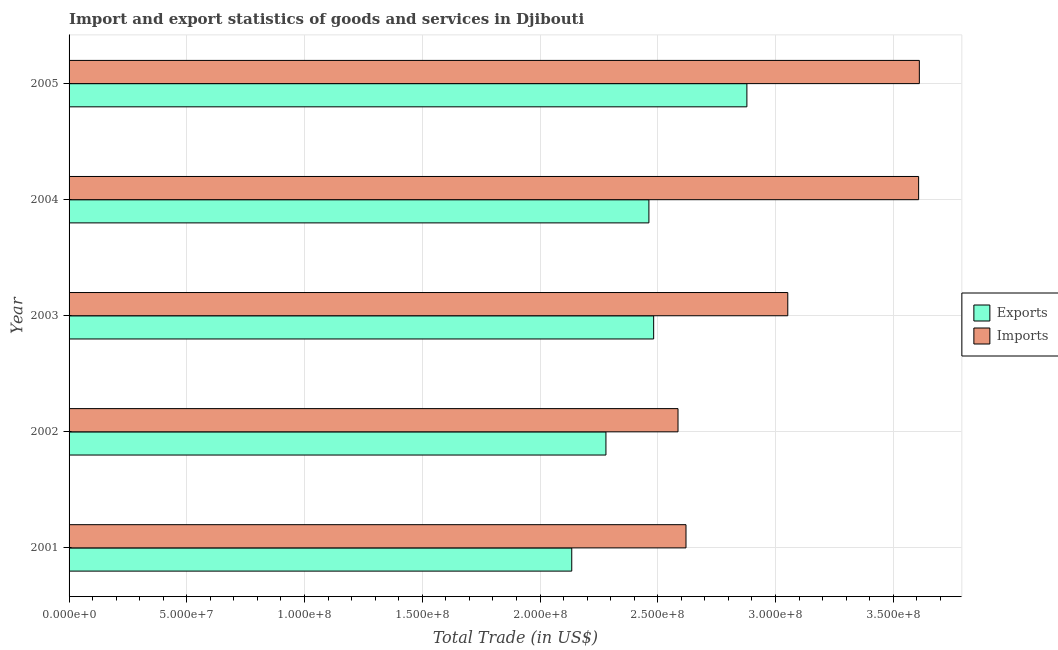How many different coloured bars are there?
Your answer should be compact. 2. How many groups of bars are there?
Offer a terse response. 5. Are the number of bars per tick equal to the number of legend labels?
Make the answer very short. Yes. How many bars are there on the 1st tick from the bottom?
Make the answer very short. 2. In how many cases, is the number of bars for a given year not equal to the number of legend labels?
Make the answer very short. 0. What is the export of goods and services in 2001?
Keep it short and to the point. 2.13e+08. Across all years, what is the maximum export of goods and services?
Provide a short and direct response. 2.88e+08. Across all years, what is the minimum export of goods and services?
Provide a succinct answer. 2.13e+08. In which year was the export of goods and services maximum?
Provide a succinct answer. 2005. What is the total imports of goods and services in the graph?
Provide a succinct answer. 1.55e+09. What is the difference between the export of goods and services in 2003 and that in 2005?
Keep it short and to the point. -3.96e+07. What is the difference between the export of goods and services in 2003 and the imports of goods and services in 2001?
Keep it short and to the point. -1.37e+07. What is the average export of goods and services per year?
Make the answer very short. 2.45e+08. In the year 2003, what is the difference between the imports of goods and services and export of goods and services?
Offer a very short reply. 5.70e+07. What is the ratio of the export of goods and services in 2004 to that in 2005?
Your answer should be compact. 0.85. Is the export of goods and services in 2001 less than that in 2004?
Give a very brief answer. Yes. Is the difference between the imports of goods and services in 2003 and 2004 greater than the difference between the export of goods and services in 2003 and 2004?
Your answer should be compact. No. What is the difference between the highest and the second highest imports of goods and services?
Your answer should be compact. 3.00e+05. What is the difference between the highest and the lowest imports of goods and services?
Provide a succinct answer. 1.02e+08. In how many years, is the export of goods and services greater than the average export of goods and services taken over all years?
Offer a very short reply. 3. What does the 1st bar from the top in 2003 represents?
Give a very brief answer. Imports. What does the 1st bar from the bottom in 2004 represents?
Your answer should be compact. Exports. How many bars are there?
Your answer should be very brief. 10. What is the difference between two consecutive major ticks on the X-axis?
Make the answer very short. 5.00e+07. Where does the legend appear in the graph?
Your answer should be compact. Center right. How are the legend labels stacked?
Keep it short and to the point. Vertical. What is the title of the graph?
Provide a succinct answer. Import and export statistics of goods and services in Djibouti. Does "Number of departures" appear as one of the legend labels in the graph?
Make the answer very short. No. What is the label or title of the X-axis?
Provide a succinct answer. Total Trade (in US$). What is the label or title of the Y-axis?
Make the answer very short. Year. What is the Total Trade (in US$) in Exports in 2001?
Offer a very short reply. 2.13e+08. What is the Total Trade (in US$) in Imports in 2001?
Provide a succinct answer. 2.62e+08. What is the Total Trade (in US$) in Exports in 2002?
Offer a very short reply. 2.28e+08. What is the Total Trade (in US$) in Imports in 2002?
Make the answer very short. 2.59e+08. What is the Total Trade (in US$) of Exports in 2003?
Your response must be concise. 2.48e+08. What is the Total Trade (in US$) in Imports in 2003?
Your response must be concise. 3.05e+08. What is the Total Trade (in US$) in Exports in 2004?
Ensure brevity in your answer.  2.46e+08. What is the Total Trade (in US$) in Imports in 2004?
Offer a terse response. 3.61e+08. What is the Total Trade (in US$) of Exports in 2005?
Keep it short and to the point. 2.88e+08. What is the Total Trade (in US$) of Imports in 2005?
Your response must be concise. 3.61e+08. Across all years, what is the maximum Total Trade (in US$) in Exports?
Make the answer very short. 2.88e+08. Across all years, what is the maximum Total Trade (in US$) of Imports?
Provide a succinct answer. 3.61e+08. Across all years, what is the minimum Total Trade (in US$) in Exports?
Ensure brevity in your answer.  2.13e+08. Across all years, what is the minimum Total Trade (in US$) in Imports?
Offer a terse response. 2.59e+08. What is the total Total Trade (in US$) of Exports in the graph?
Provide a succinct answer. 1.22e+09. What is the total Total Trade (in US$) of Imports in the graph?
Offer a very short reply. 1.55e+09. What is the difference between the Total Trade (in US$) of Exports in 2001 and that in 2002?
Offer a very short reply. -1.45e+07. What is the difference between the Total Trade (in US$) in Imports in 2001 and that in 2002?
Provide a succinct answer. 3.39e+06. What is the difference between the Total Trade (in US$) of Exports in 2001 and that in 2003?
Make the answer very short. -3.48e+07. What is the difference between the Total Trade (in US$) in Imports in 2001 and that in 2003?
Give a very brief answer. -4.32e+07. What is the difference between the Total Trade (in US$) of Exports in 2001 and that in 2004?
Offer a terse response. -3.28e+07. What is the difference between the Total Trade (in US$) in Imports in 2001 and that in 2004?
Offer a terse response. -9.88e+07. What is the difference between the Total Trade (in US$) of Exports in 2001 and that in 2005?
Offer a very short reply. -7.44e+07. What is the difference between the Total Trade (in US$) in Imports in 2001 and that in 2005?
Offer a very short reply. -9.91e+07. What is the difference between the Total Trade (in US$) of Exports in 2002 and that in 2003?
Offer a very short reply. -2.03e+07. What is the difference between the Total Trade (in US$) in Imports in 2002 and that in 2003?
Provide a short and direct response. -4.66e+07. What is the difference between the Total Trade (in US$) of Exports in 2002 and that in 2004?
Provide a succinct answer. -1.82e+07. What is the difference between the Total Trade (in US$) in Imports in 2002 and that in 2004?
Offer a very short reply. -1.02e+08. What is the difference between the Total Trade (in US$) of Exports in 2002 and that in 2005?
Provide a short and direct response. -5.99e+07. What is the difference between the Total Trade (in US$) in Imports in 2002 and that in 2005?
Provide a succinct answer. -1.02e+08. What is the difference between the Total Trade (in US$) of Exports in 2003 and that in 2004?
Provide a short and direct response. 2.02e+06. What is the difference between the Total Trade (in US$) in Imports in 2003 and that in 2004?
Your answer should be very brief. -5.56e+07. What is the difference between the Total Trade (in US$) of Exports in 2003 and that in 2005?
Keep it short and to the point. -3.96e+07. What is the difference between the Total Trade (in US$) in Imports in 2003 and that in 2005?
Ensure brevity in your answer.  -5.59e+07. What is the difference between the Total Trade (in US$) of Exports in 2004 and that in 2005?
Make the answer very short. -4.16e+07. What is the difference between the Total Trade (in US$) in Imports in 2004 and that in 2005?
Your answer should be compact. -3.00e+05. What is the difference between the Total Trade (in US$) of Exports in 2001 and the Total Trade (in US$) of Imports in 2002?
Your response must be concise. -4.51e+07. What is the difference between the Total Trade (in US$) of Exports in 2001 and the Total Trade (in US$) of Imports in 2003?
Keep it short and to the point. -9.18e+07. What is the difference between the Total Trade (in US$) of Exports in 2001 and the Total Trade (in US$) of Imports in 2004?
Your answer should be compact. -1.47e+08. What is the difference between the Total Trade (in US$) in Exports in 2001 and the Total Trade (in US$) in Imports in 2005?
Make the answer very short. -1.48e+08. What is the difference between the Total Trade (in US$) of Exports in 2002 and the Total Trade (in US$) of Imports in 2003?
Provide a succinct answer. -7.72e+07. What is the difference between the Total Trade (in US$) in Exports in 2002 and the Total Trade (in US$) in Imports in 2004?
Offer a terse response. -1.33e+08. What is the difference between the Total Trade (in US$) of Exports in 2002 and the Total Trade (in US$) of Imports in 2005?
Give a very brief answer. -1.33e+08. What is the difference between the Total Trade (in US$) in Exports in 2003 and the Total Trade (in US$) in Imports in 2004?
Your response must be concise. -1.13e+08. What is the difference between the Total Trade (in US$) in Exports in 2003 and the Total Trade (in US$) in Imports in 2005?
Offer a terse response. -1.13e+08. What is the difference between the Total Trade (in US$) in Exports in 2004 and the Total Trade (in US$) in Imports in 2005?
Offer a terse response. -1.15e+08. What is the average Total Trade (in US$) in Exports per year?
Provide a short and direct response. 2.45e+08. What is the average Total Trade (in US$) in Imports per year?
Make the answer very short. 3.10e+08. In the year 2001, what is the difference between the Total Trade (in US$) of Exports and Total Trade (in US$) of Imports?
Ensure brevity in your answer.  -4.85e+07. In the year 2002, what is the difference between the Total Trade (in US$) of Exports and Total Trade (in US$) of Imports?
Make the answer very short. -3.06e+07. In the year 2003, what is the difference between the Total Trade (in US$) of Exports and Total Trade (in US$) of Imports?
Your response must be concise. -5.70e+07. In the year 2004, what is the difference between the Total Trade (in US$) in Exports and Total Trade (in US$) in Imports?
Provide a short and direct response. -1.15e+08. In the year 2005, what is the difference between the Total Trade (in US$) in Exports and Total Trade (in US$) in Imports?
Offer a terse response. -7.32e+07. What is the ratio of the Total Trade (in US$) of Exports in 2001 to that in 2002?
Keep it short and to the point. 0.94. What is the ratio of the Total Trade (in US$) of Imports in 2001 to that in 2002?
Provide a short and direct response. 1.01. What is the ratio of the Total Trade (in US$) in Exports in 2001 to that in 2003?
Keep it short and to the point. 0.86. What is the ratio of the Total Trade (in US$) in Imports in 2001 to that in 2003?
Offer a terse response. 0.86. What is the ratio of the Total Trade (in US$) in Exports in 2001 to that in 2004?
Your response must be concise. 0.87. What is the ratio of the Total Trade (in US$) in Imports in 2001 to that in 2004?
Provide a succinct answer. 0.73. What is the ratio of the Total Trade (in US$) in Exports in 2001 to that in 2005?
Your response must be concise. 0.74. What is the ratio of the Total Trade (in US$) in Imports in 2001 to that in 2005?
Provide a short and direct response. 0.73. What is the ratio of the Total Trade (in US$) of Exports in 2002 to that in 2003?
Provide a succinct answer. 0.92. What is the ratio of the Total Trade (in US$) in Imports in 2002 to that in 2003?
Keep it short and to the point. 0.85. What is the ratio of the Total Trade (in US$) of Exports in 2002 to that in 2004?
Make the answer very short. 0.93. What is the ratio of the Total Trade (in US$) of Imports in 2002 to that in 2004?
Provide a short and direct response. 0.72. What is the ratio of the Total Trade (in US$) in Exports in 2002 to that in 2005?
Your response must be concise. 0.79. What is the ratio of the Total Trade (in US$) of Imports in 2002 to that in 2005?
Your answer should be very brief. 0.72. What is the ratio of the Total Trade (in US$) in Exports in 2003 to that in 2004?
Ensure brevity in your answer.  1.01. What is the ratio of the Total Trade (in US$) in Imports in 2003 to that in 2004?
Give a very brief answer. 0.85. What is the ratio of the Total Trade (in US$) in Exports in 2003 to that in 2005?
Your answer should be very brief. 0.86. What is the ratio of the Total Trade (in US$) in Imports in 2003 to that in 2005?
Offer a terse response. 0.85. What is the ratio of the Total Trade (in US$) of Exports in 2004 to that in 2005?
Your response must be concise. 0.86. What is the ratio of the Total Trade (in US$) in Imports in 2004 to that in 2005?
Your response must be concise. 1. What is the difference between the highest and the second highest Total Trade (in US$) in Exports?
Ensure brevity in your answer.  3.96e+07. What is the difference between the highest and the second highest Total Trade (in US$) of Imports?
Ensure brevity in your answer.  3.00e+05. What is the difference between the highest and the lowest Total Trade (in US$) in Exports?
Make the answer very short. 7.44e+07. What is the difference between the highest and the lowest Total Trade (in US$) of Imports?
Ensure brevity in your answer.  1.02e+08. 